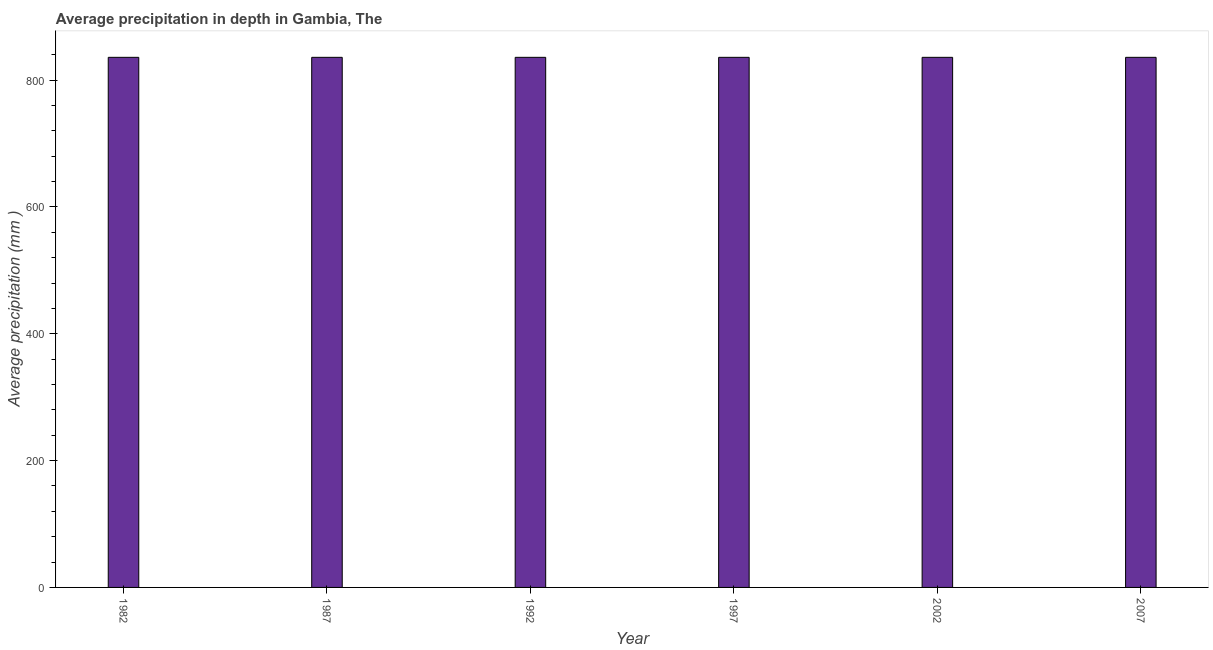Does the graph contain any zero values?
Make the answer very short. No. Does the graph contain grids?
Your answer should be very brief. No. What is the title of the graph?
Offer a terse response. Average precipitation in depth in Gambia, The. What is the label or title of the X-axis?
Provide a short and direct response. Year. What is the label or title of the Y-axis?
Your answer should be very brief. Average precipitation (mm ). What is the average precipitation in depth in 1997?
Provide a succinct answer. 836. Across all years, what is the maximum average precipitation in depth?
Your response must be concise. 836. Across all years, what is the minimum average precipitation in depth?
Make the answer very short. 836. In which year was the average precipitation in depth maximum?
Give a very brief answer. 1982. What is the sum of the average precipitation in depth?
Make the answer very short. 5016. What is the average average precipitation in depth per year?
Offer a terse response. 836. What is the median average precipitation in depth?
Ensure brevity in your answer.  836. In how many years, is the average precipitation in depth greater than 560 mm?
Ensure brevity in your answer.  6. Is the average precipitation in depth in 1987 less than that in 1992?
Provide a succinct answer. No. Is the sum of the average precipitation in depth in 1997 and 2002 greater than the maximum average precipitation in depth across all years?
Your response must be concise. Yes. What is the difference between the highest and the lowest average precipitation in depth?
Provide a short and direct response. 0. In how many years, is the average precipitation in depth greater than the average average precipitation in depth taken over all years?
Keep it short and to the point. 0. What is the difference between two consecutive major ticks on the Y-axis?
Give a very brief answer. 200. What is the Average precipitation (mm ) in 1982?
Provide a succinct answer. 836. What is the Average precipitation (mm ) of 1987?
Provide a short and direct response. 836. What is the Average precipitation (mm ) of 1992?
Provide a succinct answer. 836. What is the Average precipitation (mm ) of 1997?
Provide a succinct answer. 836. What is the Average precipitation (mm ) in 2002?
Your answer should be compact. 836. What is the Average precipitation (mm ) in 2007?
Offer a terse response. 836. What is the difference between the Average precipitation (mm ) in 1982 and 1987?
Keep it short and to the point. 0. What is the difference between the Average precipitation (mm ) in 1982 and 1992?
Offer a very short reply. 0. What is the difference between the Average precipitation (mm ) in 1987 and 1992?
Provide a succinct answer. 0. What is the difference between the Average precipitation (mm ) in 1987 and 1997?
Provide a succinct answer. 0. What is the difference between the Average precipitation (mm ) in 1987 and 2007?
Your answer should be very brief. 0. What is the difference between the Average precipitation (mm ) in 1992 and 1997?
Provide a succinct answer. 0. What is the difference between the Average precipitation (mm ) in 1992 and 2002?
Provide a succinct answer. 0. What is the difference between the Average precipitation (mm ) in 1997 and 2002?
Provide a succinct answer. 0. What is the difference between the Average precipitation (mm ) in 2002 and 2007?
Your answer should be compact. 0. What is the ratio of the Average precipitation (mm ) in 1982 to that in 1992?
Your answer should be very brief. 1. What is the ratio of the Average precipitation (mm ) in 1982 to that in 2007?
Offer a very short reply. 1. What is the ratio of the Average precipitation (mm ) in 1987 to that in 1992?
Offer a very short reply. 1. What is the ratio of the Average precipitation (mm ) in 1987 to that in 1997?
Keep it short and to the point. 1. What is the ratio of the Average precipitation (mm ) in 1992 to that in 1997?
Make the answer very short. 1. What is the ratio of the Average precipitation (mm ) in 1992 to that in 2007?
Give a very brief answer. 1. 